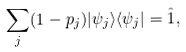<formula> <loc_0><loc_0><loc_500><loc_500>\sum _ { j } ( 1 - p _ { j } ) | \psi _ { j } \rangle \langle \psi _ { j } | = \hat { 1 } ,</formula> 